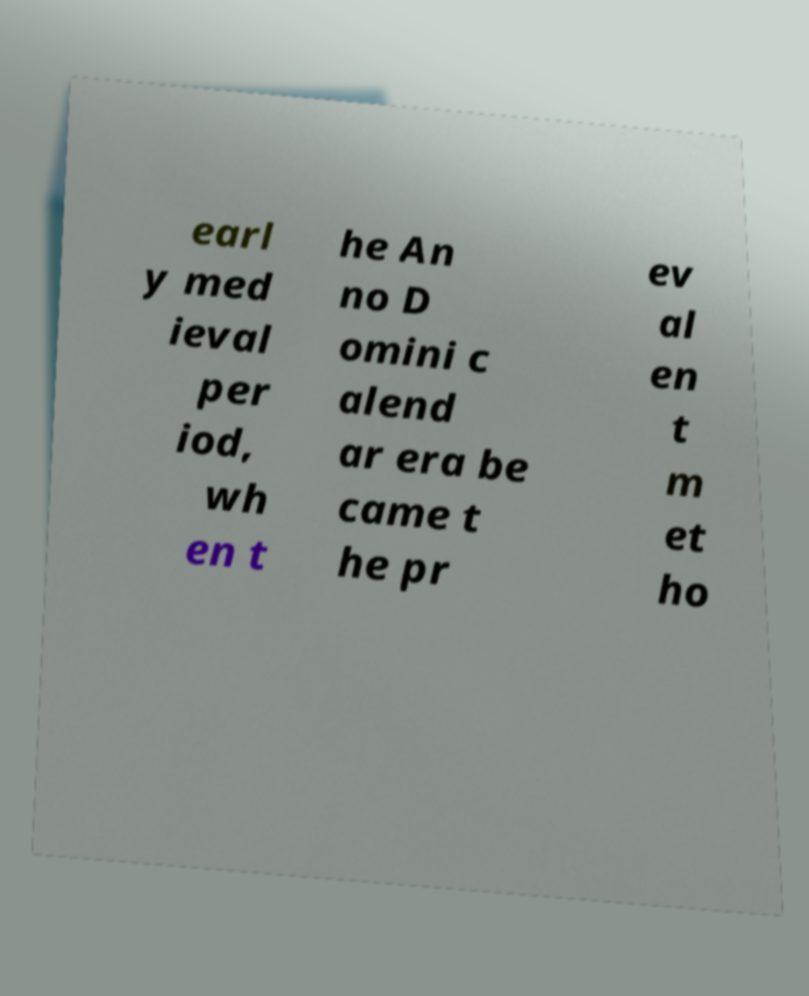For documentation purposes, I need the text within this image transcribed. Could you provide that? earl y med ieval per iod, wh en t he An no D omini c alend ar era be came t he pr ev al en t m et ho 